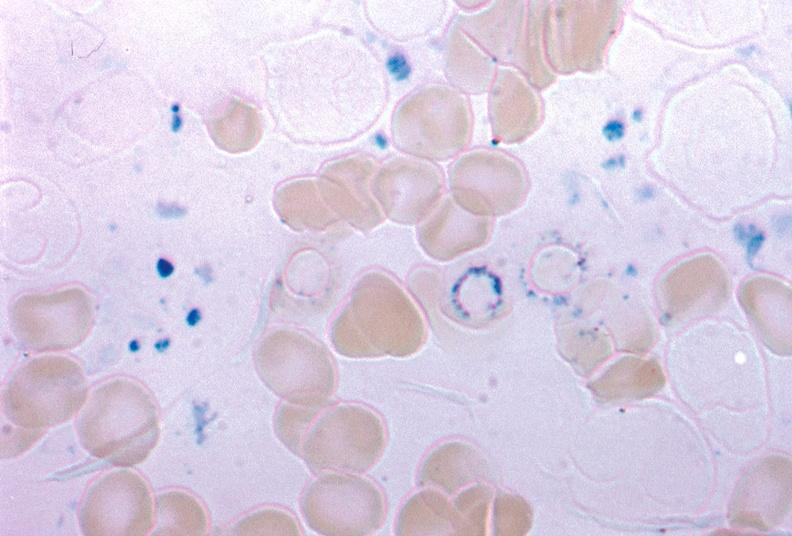does infant body show iron stain excellent example source unknown?
Answer the question using a single word or phrase. No 